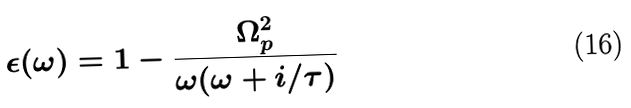Convert formula to latex. <formula><loc_0><loc_0><loc_500><loc_500>\epsilon ( \omega ) = 1 - \frac { \Omega _ { p } ^ { 2 } } { \omega ( \omega + i / \tau ) }</formula> 